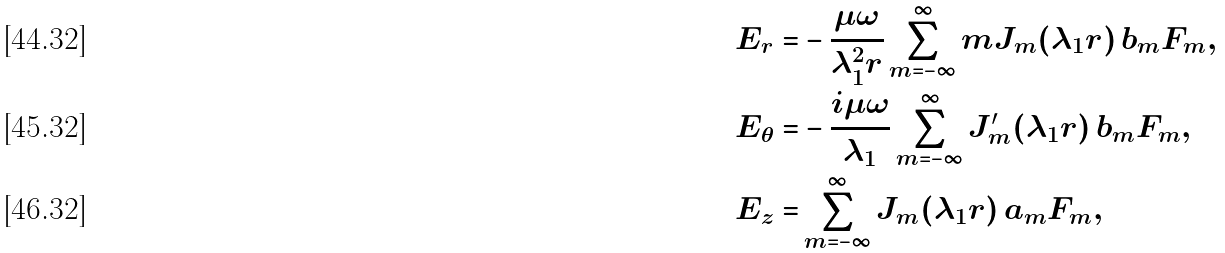<formula> <loc_0><loc_0><loc_500><loc_500>E _ { r } = & - \frac { \mu \omega } { \lambda _ { 1 } ^ { 2 } r } \sum _ { m = - \infty } ^ { \infty } m J _ { m } ( \lambda _ { 1 } r ) \, b _ { m } F _ { m } , \\ E _ { \theta } = & - \frac { i \mu \omega } { \lambda _ { 1 } } \sum _ { m = - \infty } ^ { \infty } J _ { m } ^ { \prime } ( \lambda _ { 1 } r ) \, b _ { m } F _ { m } , \\ E _ { z } = & \sum _ { m = - \infty } ^ { \infty } J _ { m } ( \lambda _ { 1 } r ) \, a _ { m } F _ { m } ,</formula> 